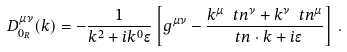<formula> <loc_0><loc_0><loc_500><loc_500>D ^ { \mu \nu } _ { 0 _ { R } } ( k ) = - \frac { 1 } { k ^ { 2 } + i k ^ { 0 } \epsilon } \left [ g ^ { \mu \nu } - \frac { k ^ { \mu } \ t n ^ { \nu } + k ^ { \nu } \ t n ^ { \mu } } { \ t n \cdot k + i \epsilon } \right ] \, .</formula> 